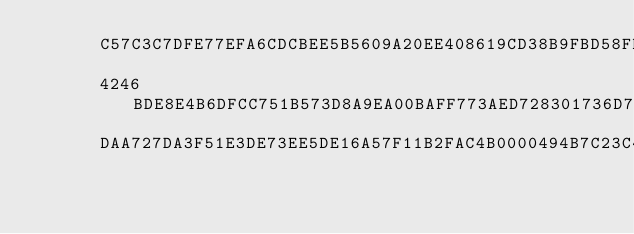<code> <loc_0><loc_0><loc_500><loc_500><_Pascal_>      C57C3C7DFE77EFA6CDCBEE5B5609A20EE408619CD38B9FBD58FD96D76E592E23
      4246BDE8E4B6DFCC751B573D8A9EA00BAFF773AED728301736D715684B59B6BF
      DAA727DA3F51E3DE73EE5DE16A57F11B2FAC4B0000494B7C23C4C1649BC7DF7F</code> 